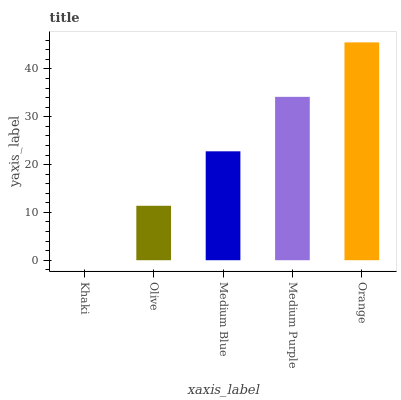Is Khaki the minimum?
Answer yes or no. Yes. Is Orange the maximum?
Answer yes or no. Yes. Is Olive the minimum?
Answer yes or no. No. Is Olive the maximum?
Answer yes or no. No. Is Olive greater than Khaki?
Answer yes or no. Yes. Is Khaki less than Olive?
Answer yes or no. Yes. Is Khaki greater than Olive?
Answer yes or no. No. Is Olive less than Khaki?
Answer yes or no. No. Is Medium Blue the high median?
Answer yes or no. Yes. Is Medium Blue the low median?
Answer yes or no. Yes. Is Orange the high median?
Answer yes or no. No. Is Orange the low median?
Answer yes or no. No. 